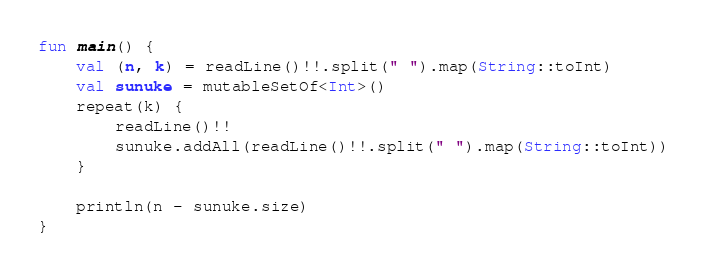Convert code to text. <code><loc_0><loc_0><loc_500><loc_500><_Kotlin_>fun main() {
    val (n, k) = readLine()!!.split(" ").map(String::toInt)
    val sunuke = mutableSetOf<Int>()
    repeat(k) {
        readLine()!!
        sunuke.addAll(readLine()!!.split(" ").map(String::toInt))
    }

    println(n - sunuke.size)
}



</code> 